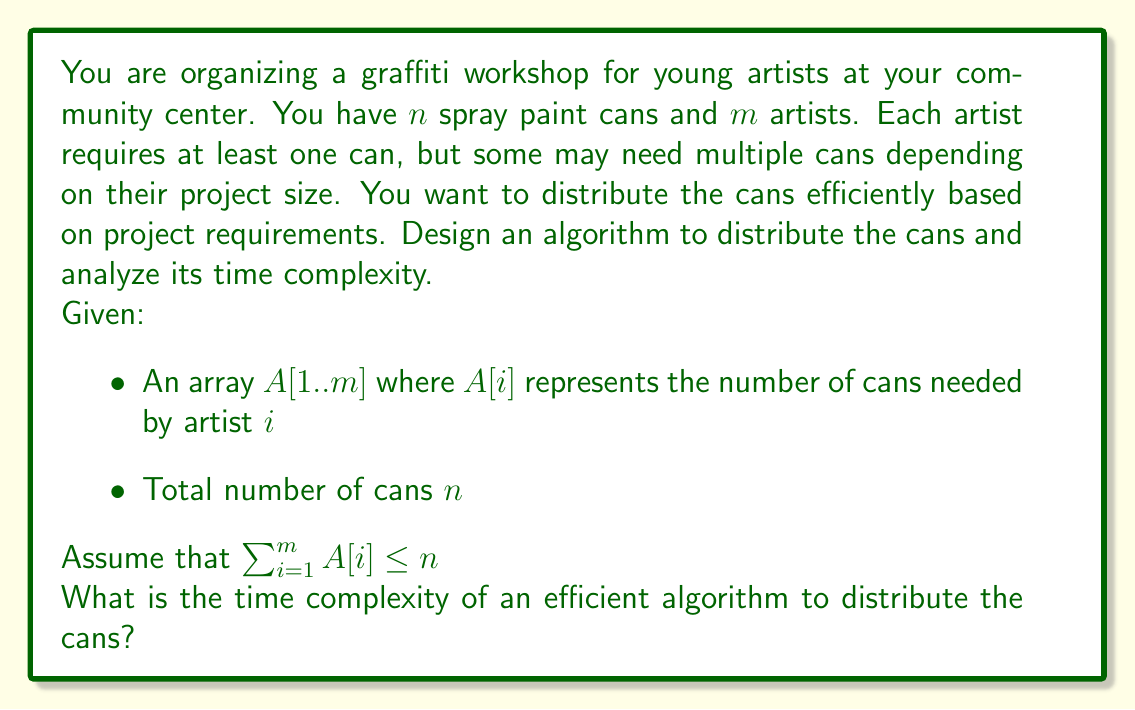Give your solution to this math problem. To solve this problem efficiently, we can use a simple greedy approach. Here's the algorithm and its analysis:

1. Sort the array $A$ in descending order. This ensures we handle the artists with the highest demand first.
   Time complexity: $O(m \log m)$ using an efficient sorting algorithm like Merge Sort or Quick Sort.

2. Iterate through the sorted array and distribute cans to each artist:
   ```
   for i = 1 to m:
       distribute A[i] cans to artist i
   ```
   Time complexity: $O(m)$

3. If there are any remaining cans, distribute them evenly or based on a secondary criterion.
   Time complexity: $O(n - \sum A[i])$ in the worst case, which is bounded by $O(n)$.

The total time complexity is the sum of these steps:

$$ T(n, m) = O(m \log m) + O(m) + O(n) $$

Since $n \geq m$ (as each artist needs at least one can), we can simplify this to:

$$ T(n, m) = O(m \log m + n) $$

This algorithm is efficient because it handles the distribution in a single pass after sorting, and the sorting step allows us to satisfy the artists with the highest demands first, reducing the chance of conflicts or rearrangements.
Answer: The time complexity of an efficient algorithm to distribute the spray paint cans is $O(m \log m + n)$, where $m$ is the number of artists and $n$ is the total number of cans. 